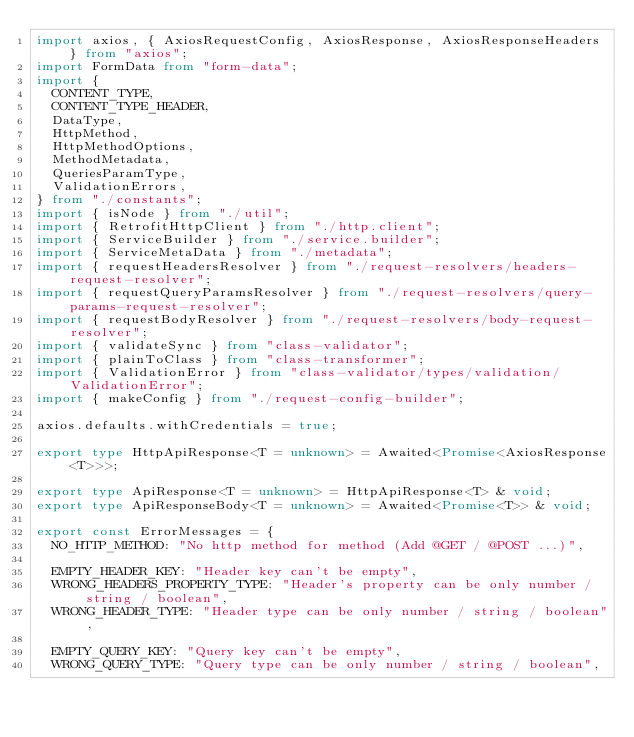Convert code to text. <code><loc_0><loc_0><loc_500><loc_500><_TypeScript_>import axios, { AxiosRequestConfig, AxiosResponse, AxiosResponseHeaders } from "axios";
import FormData from "form-data";
import {
  CONTENT_TYPE,
  CONTENT_TYPE_HEADER,
  DataType,
  HttpMethod,
  HttpMethodOptions,
  MethodMetadata,
  QueriesParamType,
  ValidationErrors,
} from "./constants";
import { isNode } from "./util";
import { RetrofitHttpClient } from "./http.client";
import { ServiceBuilder } from "./service.builder";
import { ServiceMetaData } from "./metadata";
import { requestHeadersResolver } from "./request-resolvers/headers-request-resolver";
import { requestQueryParamsResolver } from "./request-resolvers/query-params-request-resolver";
import { requestBodyResolver } from "./request-resolvers/body-request-resolver";
import { validateSync } from "class-validator";
import { plainToClass } from "class-transformer";
import { ValidationError } from "class-validator/types/validation/ValidationError";
import { makeConfig } from "./request-config-builder";

axios.defaults.withCredentials = true;

export type HttpApiResponse<T = unknown> = Awaited<Promise<AxiosResponse<T>>>;

export type ApiResponse<T = unknown> = HttpApiResponse<T> & void;
export type ApiResponseBody<T = unknown> = Awaited<Promise<T>> & void;

export const ErrorMessages = {
  NO_HTTP_METHOD: "No http method for method (Add @GET / @POST ...)",

  EMPTY_HEADER_KEY: "Header key can't be empty",
  WRONG_HEADERS_PROPERTY_TYPE: "Header's property can be only number / string / boolean",
  WRONG_HEADER_TYPE: "Header type can be only number / string / boolean",

  EMPTY_QUERY_KEY: "Query key can't be empty",
  WRONG_QUERY_TYPE: "Query type can be only number / string / boolean",</code> 